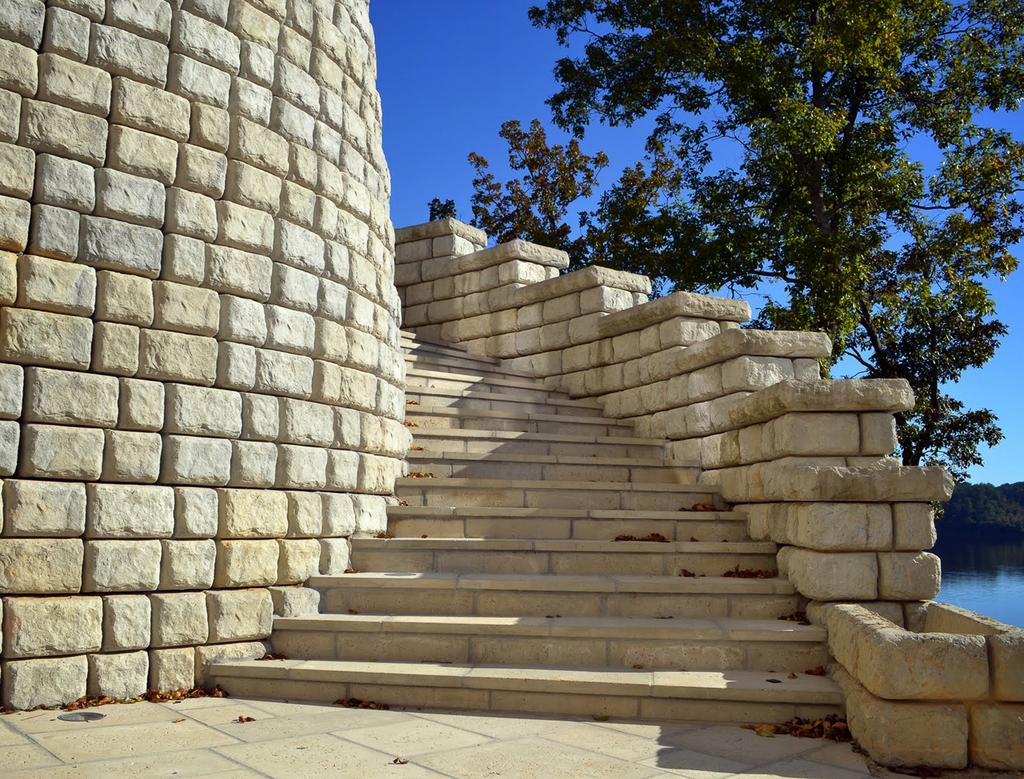What type of structures can be seen in the image? There are walls and steps in the image. What type of vegetation is present in the image? Leaves and trees are visible in the image. What natural element is present in the image? There is water in the image. What can be seen in the background of the image? The sky is visible in the background of the image. How many pies are being held by the horses in the image? There are no horses or pies present in the image. What type of arm is visible in the image? There is no arm visible in the image. 